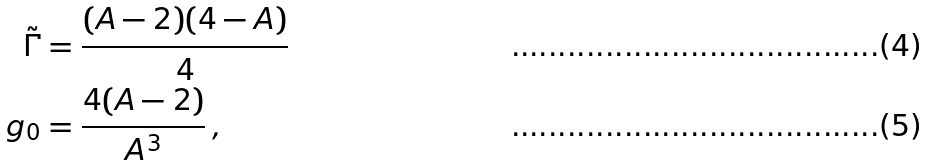<formula> <loc_0><loc_0><loc_500><loc_500>\tilde { \Gamma } & = \frac { ( A - 2 ) ( 4 - A ) } { 4 } \\ g _ { 0 } & = \frac { 4 ( A - 2 ) } { A ^ { 3 } } \, ,</formula> 